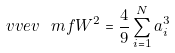Convert formula to latex. <formula><loc_0><loc_0><loc_500><loc_500>\ v v e v { \ m f { W } ^ { 2 } } = \frac { 4 } { 9 } \sum _ { i = 1 } ^ { N } a _ { i } ^ { 3 }</formula> 